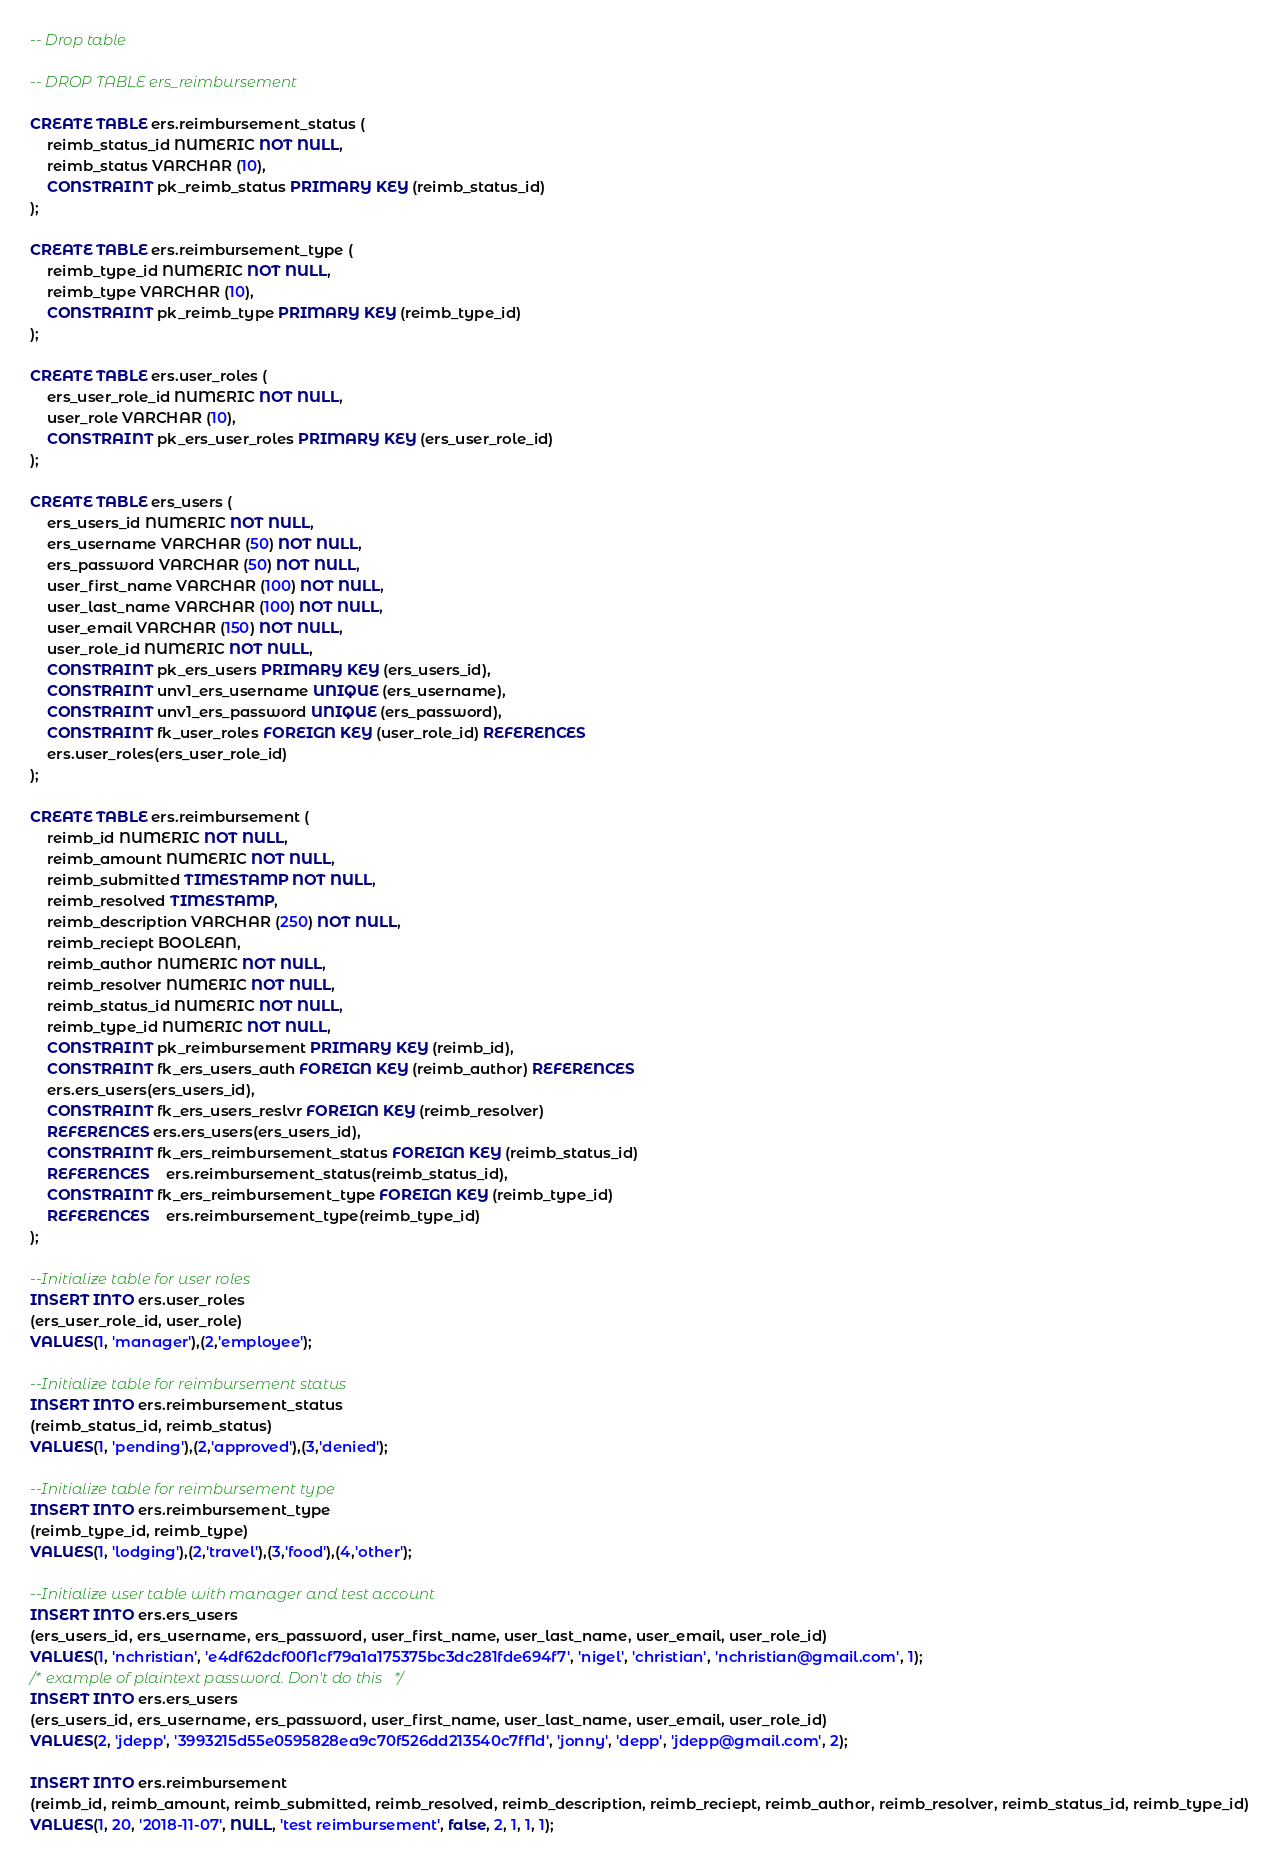Convert code to text. <code><loc_0><loc_0><loc_500><loc_500><_SQL_>-- Drop table

-- DROP TABLE ers_reimbursement

CREATE TABLE ers.reimbursement_status (
	reimb_status_id NUMERIC NOT NULL,
	reimb_status VARCHAR (10),
	CONSTRAINT pk_reimb_status PRIMARY KEY (reimb_status_id)
);

CREATE TABLE ers.reimbursement_type (
	reimb_type_id NUMERIC NOT NULL,
	reimb_type VARCHAR (10),
	CONSTRAINT pk_reimb_type PRIMARY KEY (reimb_type_id)
);

CREATE TABLE ers.user_roles (
	ers_user_role_id NUMERIC NOT NULL,
	user_role VARCHAR (10),
	CONSTRAINT pk_ers_user_roles PRIMARY KEY (ers_user_role_id)
);

CREATE TABLE ers_users (
	ers_users_id NUMERIC NOT NULL,
	ers_username VARCHAR (50) NOT NULL,
	ers_password VARCHAR (50) NOT NULL,
	user_first_name VARCHAR (100) NOT NULL,
	user_last_name VARCHAR (100) NOT NULL,
	user_email VARCHAR (150) NOT NULL,
	user_role_id NUMERIC NOT NULL,
	CONSTRAINT pk_ers_users PRIMARY KEY (ers_users_id),
	CONSTRAINT unv1_ers_username UNIQUE (ers_username),
	CONSTRAINT unv1_ers_password UNIQUE (ers_password),
	CONSTRAINT fk_user_roles FOREIGN KEY (user_role_id) REFERENCES 	
	ers.user_roles(ers_user_role_id)
);

CREATE TABLE ers.reimbursement (
	reimb_id NUMERIC NOT NULL,
	reimb_amount NUMERIC NOT NULL,
	reimb_submitted TIMESTAMP NOT NULL,
	reimb_resolved TIMESTAMP,
	reimb_description VARCHAR (250) NOT NULL,
	reimb_reciept BOOLEAN, 
	reimb_author NUMERIC NOT NULL,
	reimb_resolver NUMERIC NOT NULL,
	reimb_status_id NUMERIC NOT NULL,
	reimb_type_id NUMERIC NOT NULL,
	CONSTRAINT pk_reimbursement PRIMARY KEY (reimb_id),
	CONSTRAINT fk_ers_users_auth FOREIGN KEY (reimb_author) REFERENCES 	
	ers.ers_users(ers_users_id),
	CONSTRAINT fk_ers_users_reslvr FOREIGN KEY (reimb_resolver) 
	REFERENCES ers.ers_users(ers_users_id),
	CONSTRAINT fk_ers_reimbursement_status FOREIGN KEY (reimb_status_id) 
	REFERENCES 	ers.reimbursement_status(reimb_status_id),
	CONSTRAINT fk_ers_reimbursement_type FOREIGN KEY (reimb_type_id) 
	REFERENCES 	ers.reimbursement_type(reimb_type_id)
);

--Initialize table for user roles 
INSERT INTO ers.user_roles
(ers_user_role_id, user_role)
VALUES(1, 'manager'),(2,'employee');

--Initialize table for reimbursement status
INSERT INTO ers.reimbursement_status
(reimb_status_id, reimb_status)
VALUES(1, 'pending'),(2,'approved'),(3,'denied');

--Initialize table for reimbursement type 
INSERT INTO ers.reimbursement_type
(reimb_type_id, reimb_type)
VALUES(1, 'lodging'),(2,'travel'),(3,'food'),(4,'other');

--Initialize user table with manager and test account
INSERT INTO ers.ers_users
(ers_users_id, ers_username, ers_password, user_first_name, user_last_name, user_email, user_role_id)
VALUES(1, 'nchristian', 'e4df62dcf00f1cf79a1a175375bc3dc281fde694f7', 'nigel', 'christian', 'nchristian@gmail.com', 1);
/* example of plaintext password. Don't do this*/
INSERT INTO ers.ers_users
(ers_users_id, ers_username, ers_password, user_first_name, user_last_name, user_email, user_role_id)
VALUES(2, 'jdepp', '3993215d55e0595828ea9c70f526dd213540c7ff1d', 'jonny', 'depp', 'jdepp@gmail.com', 2);

INSERT INTO ers.reimbursement
(reimb_id, reimb_amount, reimb_submitted, reimb_resolved, reimb_description, reimb_reciept, reimb_author, reimb_resolver, reimb_status_id, reimb_type_id)
VALUES(1, 20, '2018-11-07', NULL, 'test reimbursement', false, 2, 1, 1, 1);

</code> 